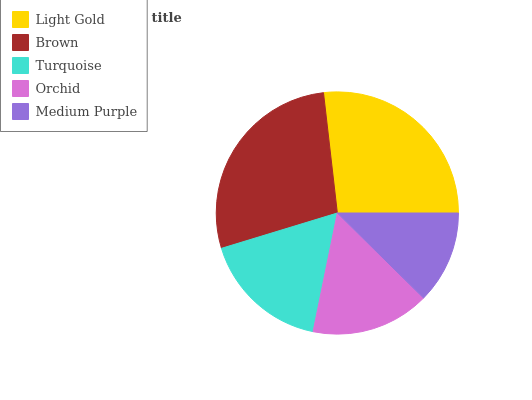Is Medium Purple the minimum?
Answer yes or no. Yes. Is Brown the maximum?
Answer yes or no. Yes. Is Turquoise the minimum?
Answer yes or no. No. Is Turquoise the maximum?
Answer yes or no. No. Is Brown greater than Turquoise?
Answer yes or no. Yes. Is Turquoise less than Brown?
Answer yes or no. Yes. Is Turquoise greater than Brown?
Answer yes or no. No. Is Brown less than Turquoise?
Answer yes or no. No. Is Turquoise the high median?
Answer yes or no. Yes. Is Turquoise the low median?
Answer yes or no. Yes. Is Orchid the high median?
Answer yes or no. No. Is Medium Purple the low median?
Answer yes or no. No. 